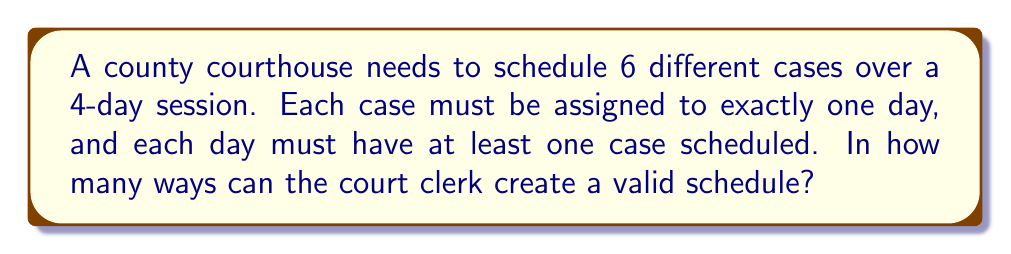Can you answer this question? Let's approach this step-by-step using the concept of Stirling numbers of the second kind and the Principle of Inclusion-Exclusion (PIE).

1) First, we need to distribute 6 cases into 4 days, ensuring each day has at least one case. This is equivalent to partitioning a set of 6 elements into 4 non-empty subsets.

2) The number of ways to partition n elements into k non-empty subsets is given by the Stirling number of the second kind, denoted as $\stirling{n}{k}$.

3) However, we need to consider all possible partitions into 1, 2, 3, or 4 non-empty subsets. We can use PIE to solve this:

   Total = $\stirling{6}{4} + \stirling{6}{3} + \stirling{6}{2} + \stirling{6}{1}$

4) Let's calculate each Stirling number:

   $\stirling{6}{4} = \frac{1}{4!}(4^6 - 4 \cdot 3^6 + 6 \cdot 2^6 - 4 \cdot 1^6) = 65$
   
   $\stirling{6}{3} = \frac{1}{3!}(3^6 - 3 \cdot 2^6 + 3 \cdot 1^6) = 90$
   
   $\stirling{6}{2} = \frac{1}{2!}(2^6 - 2 \cdot 1^6) = 31$
   
   $\stirling{6}{1} = 1$

5) Sum these up:

   Total = 65 + 90 + 31 + 1 = 187

Therefore, there are 187 possible ways to schedule the cases.
Answer: 187 